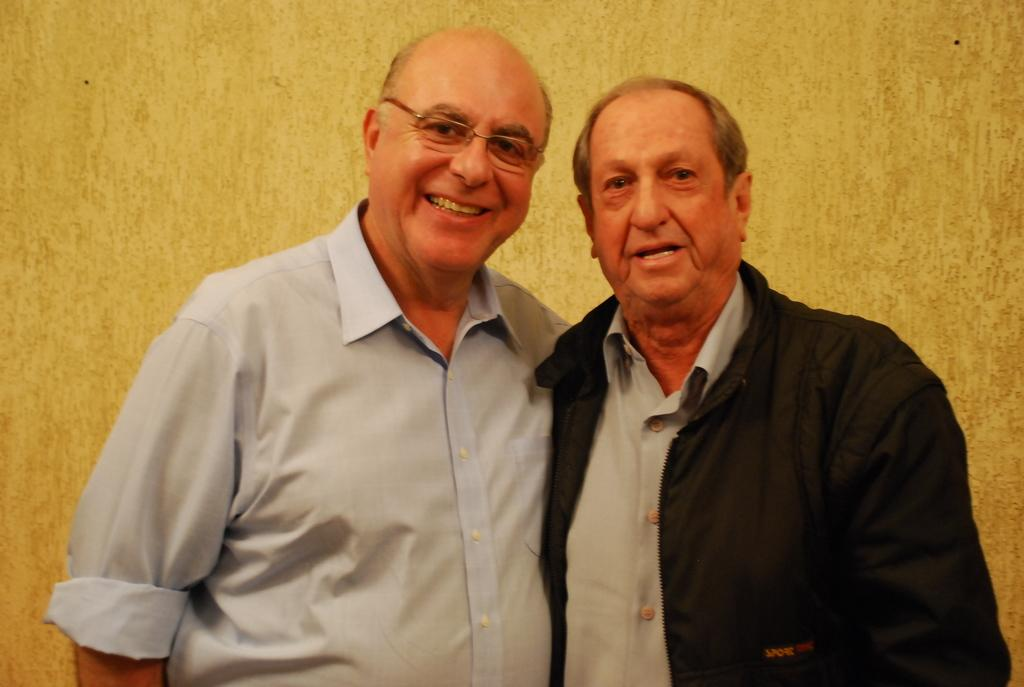How many people are in the image? There are two persons in the image. Where are the persons located in the image? The persons are standing in the background. What color is the wall in the image? The wall in the image is yellow. What type of tomatoes are being bitten by the persons in the image? There are no tomatoes or biting actions present in the image. 